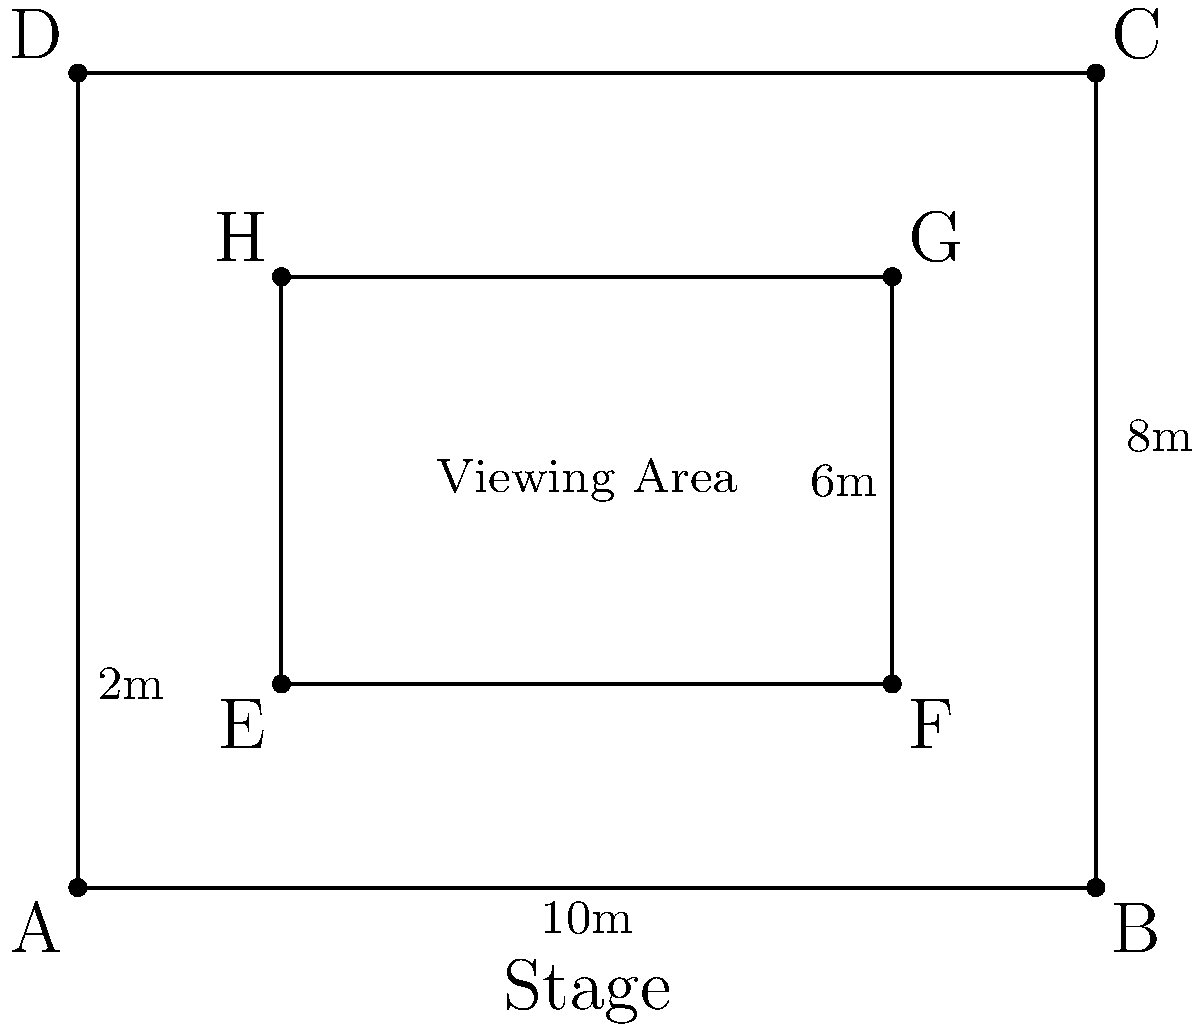At a music festival featuring Alabama, you're trying to find the best viewing spot. The stage area is represented by a 10m x 8m rectangle, with a central obstructed area of 6m x 4m where sound equipment is placed. What is the total unobstructed viewing area in square meters? To solve this problem, we'll follow these steps:

1. Calculate the total area of the stage:
   $$ A_{total} = 10m \times 8m = 80m^2 $$

2. Calculate the area of the obstructed region:
   $$ A_{obstructed} = 6m \times 4m = 24m^2 $$

3. Subtract the obstructed area from the total area to get the unobstructed viewing area:
   $$ A_{unobstructed} = A_{total} - A_{obstructed} $$
   $$ A_{unobstructed} = 80m^2 - 24m^2 = 56m^2 $$

Therefore, the total unobstructed viewing area is 56 square meters.
Answer: 56 m² 